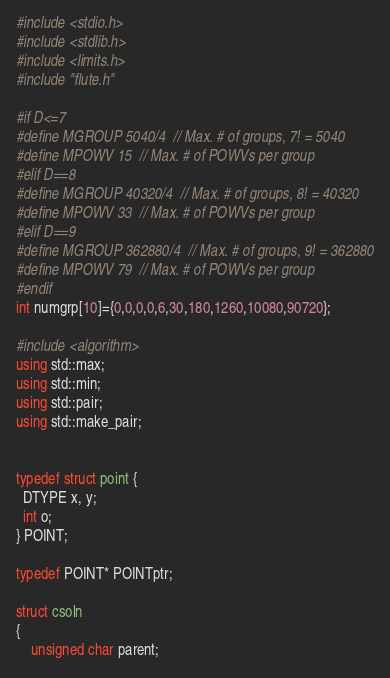Convert code to text. <code><loc_0><loc_0><loc_500><loc_500><_C++_>#include <stdio.h>
#include <stdlib.h>
#include <limits.h>
#include "flute.h"

#if D<=7
#define MGROUP 5040/4  // Max. # of groups, 7! = 5040
#define MPOWV 15  // Max. # of POWVs per group
#elif D==8
#define MGROUP 40320/4  // Max. # of groups, 8! = 40320
#define MPOWV 33  // Max. # of POWVs per group
#elif D==9
#define MGROUP 362880/4  // Max. # of groups, 9! = 362880
#define MPOWV 79  // Max. # of POWVs per group
#endif
int numgrp[10]={0,0,0,0,6,30,180,1260,10080,90720};

#include <algorithm>
using std::max;
using std::min;
using std::pair;
using std::make_pair;


typedef struct point {
  DTYPE x, y;
  int o;
} POINT;

typedef POINT* POINTptr;

struct csoln 
{
    unsigned char parent;</code> 